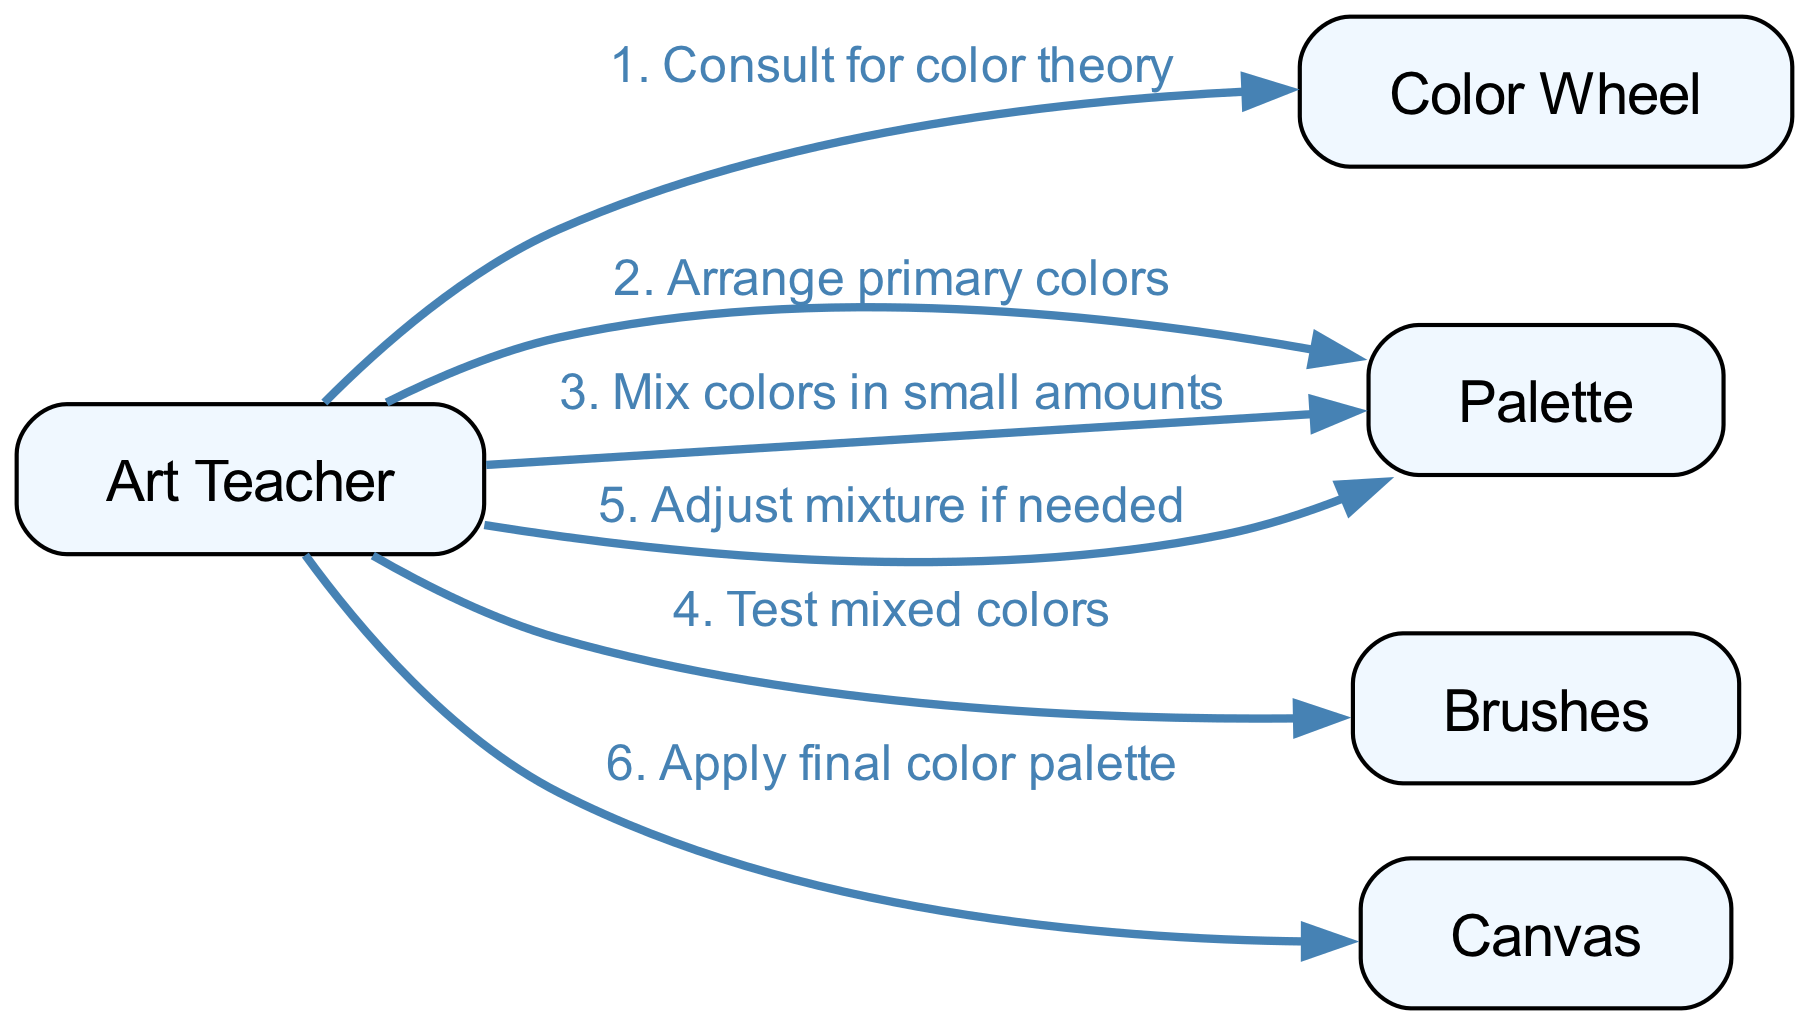What is the first action taken by the Art Teacher? The first action in the sequence indicates the Art Teacher consulting the Color Wheel for color theory. This is the initial step in the process.
Answer: Consult for color theory How many participants are involved in the diagram? By counting the unique names listed in the participants section, we find there are five distinct participants: Art Teacher, Color Wheel, Palette, Brushes, and Canvas.
Answer: 5 Which participant receives the final action? The sequence shows that the last action, applying the final color palette, is directed towards the Canvas. The Canvas is the recipient of this action.
Answer: Canvas What action follows arranging primary colors? The sequence indicates that after arranging primary colors, the Art Teacher mixes colors in small amounts next. This action directly follows the first.
Answer: Mix colors in small amounts What are the participants involved when adjusting the mixture? The participant involved when adjusting the mixture is the Palette, as the Art Teacher takes action on this participant to adjust the mixture if needed. Therefore, the only participants involved here are the Art Teacher and the Palette.
Answer: Art Teacher, Palette How many steps involve the Palette? By examining the sequence, we find that there are three actions that involve the Palette: arranging primary colors, mixing colors in small amounts, and adjusting the mixture. Counting these gives us a total of three steps.
Answer: 3 Which action occurs before testing mixed colors? The action that occurs prior to testing mixed colors is mixing colors in small amounts. This is the direct predecessor in the sequence before testing.
Answer: Mix colors in small amounts What is the relationship between the Art Teacher and the Brushes? The relationship is that the Art Teacher takes the action of testing mixed colors with the Brushes. This shows a direct action directed from the Art Teacher to the Brushes.
Answer: Tests mixed colors What is the second action taken after consulting for color theory? The second action taken after consulting for color theory is arranging primary colors on the Palette. This follows directly after the first action in the sequence.
Answer: Arrange primary colors 